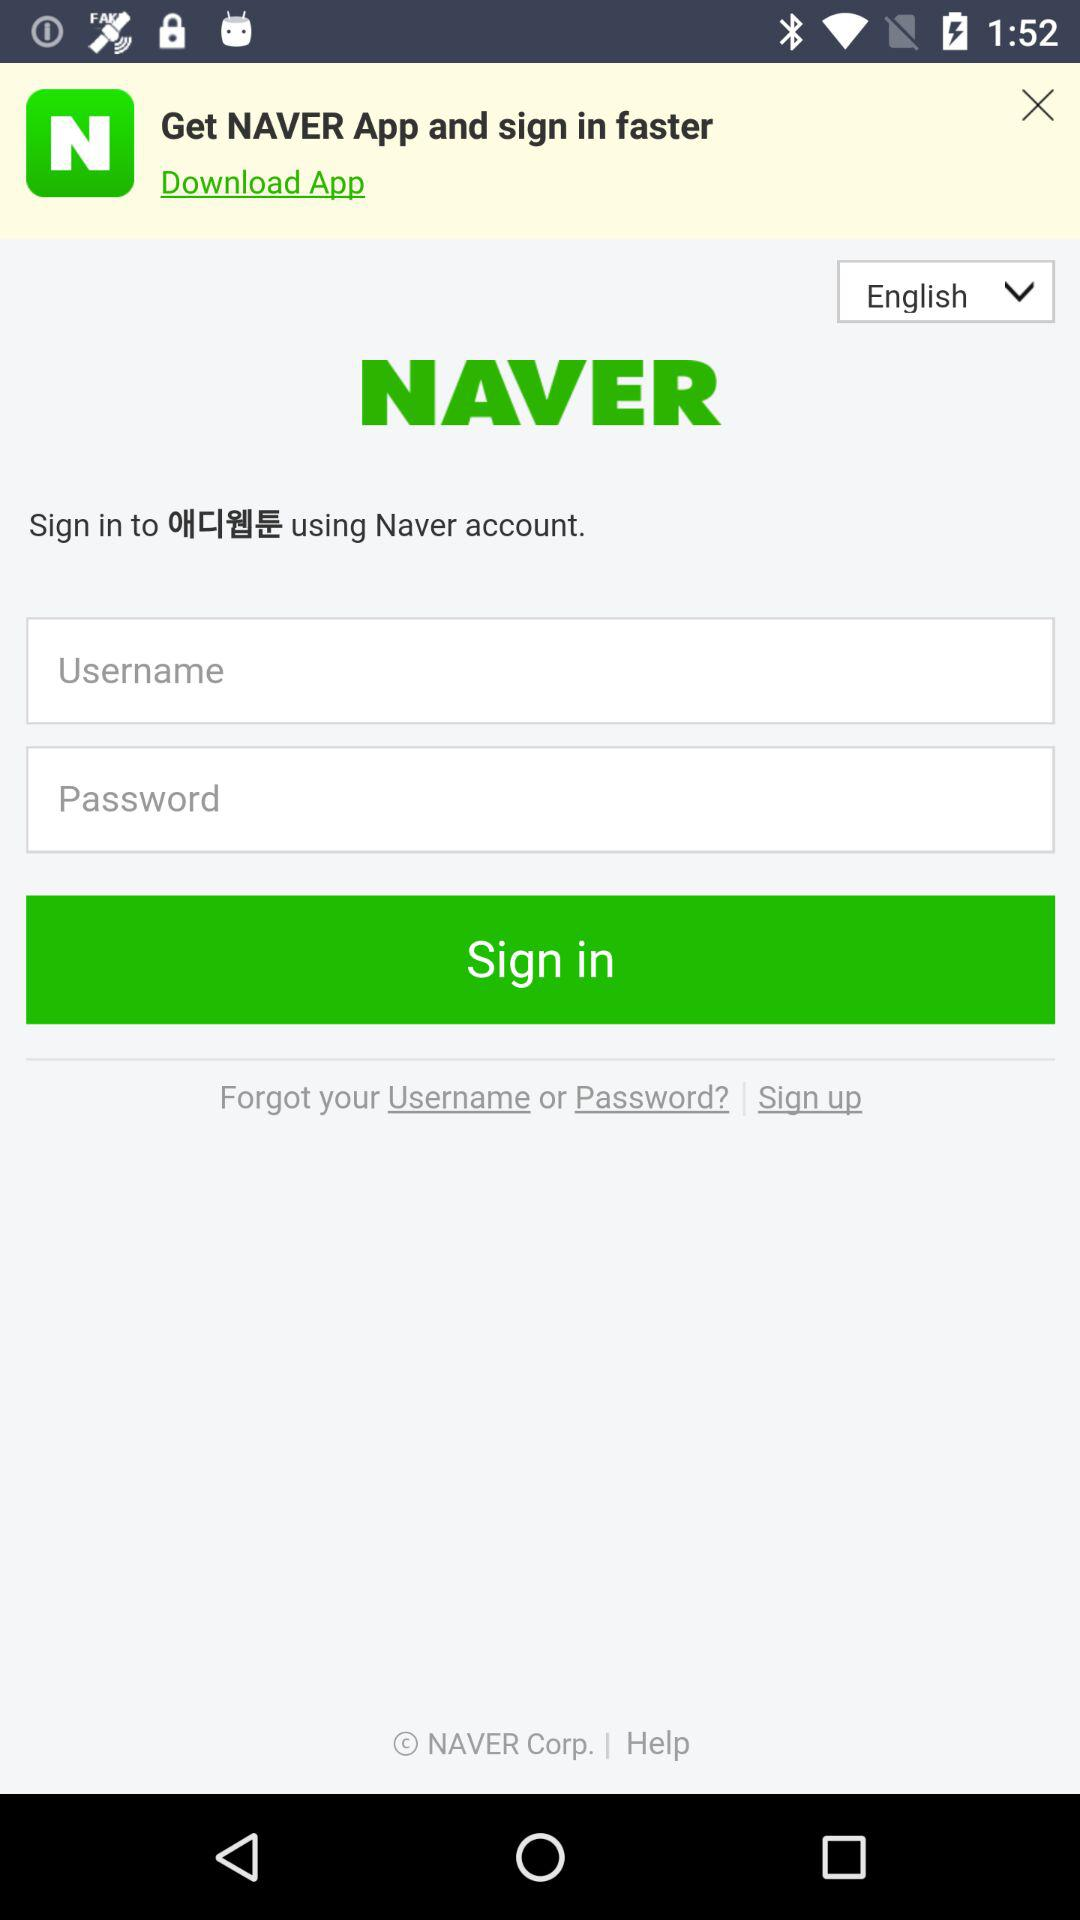What language is selected? The selected language is "English". 